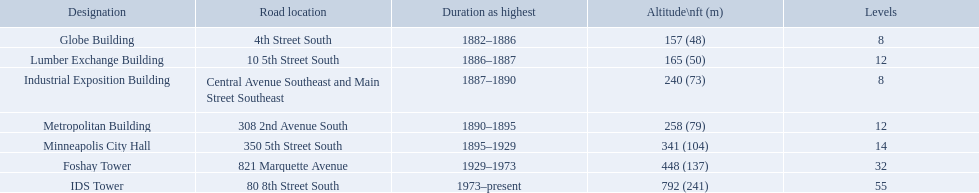What years was 240 ft considered tall? 1887–1890. What building held this record? Industrial Exposition Building. How tall is the metropolitan building? 258 (79). How tall is the lumber exchange building? 165 (50). Is the metropolitan or lumber exchange building taller? Metropolitan Building. Which buildings have the same number of floors as another building? Globe Building, Lumber Exchange Building, Industrial Exposition Building, Metropolitan Building. Of those, which has the same as the lumber exchange building? Metropolitan Building. How many floors does the globe building have? 8. Which building has 14 floors? Minneapolis City Hall. The lumber exchange building has the same number of floors as which building? Metropolitan Building. How many floors does the lumber exchange building have? 12. What other building has 12 floors? Metropolitan Building. 